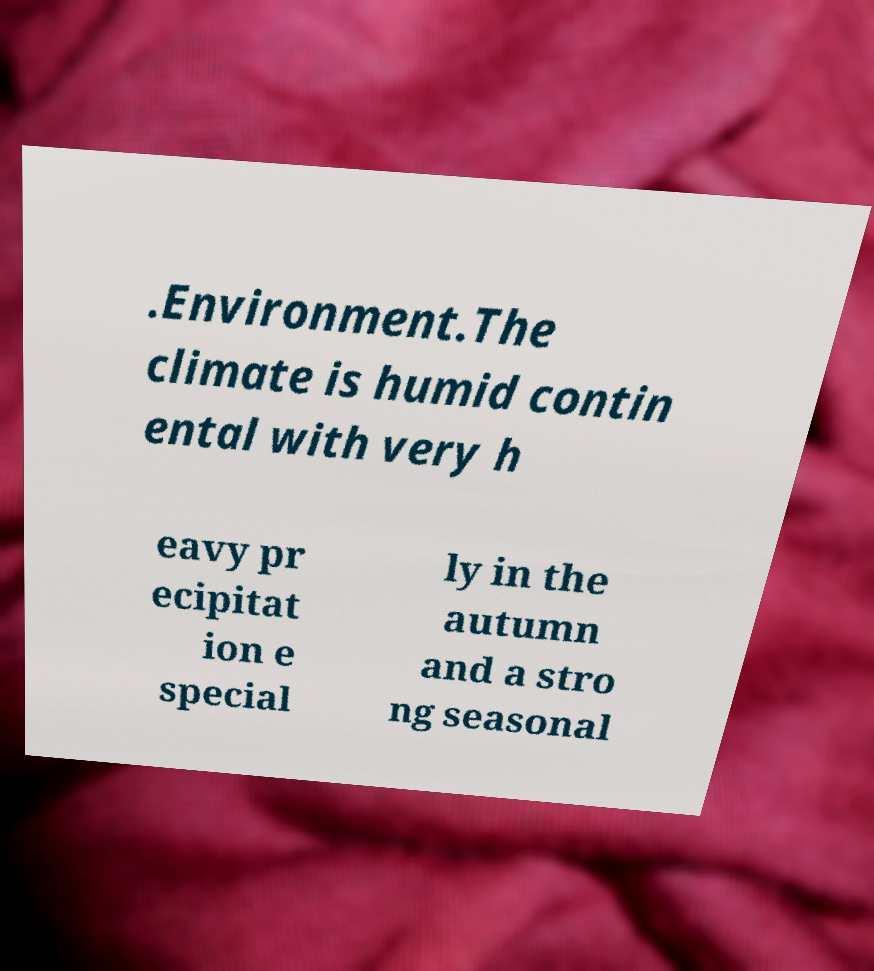Please read and relay the text visible in this image. What does it say? .Environment.The climate is humid contin ental with very h eavy pr ecipitat ion e special ly in the autumn and a stro ng seasonal 